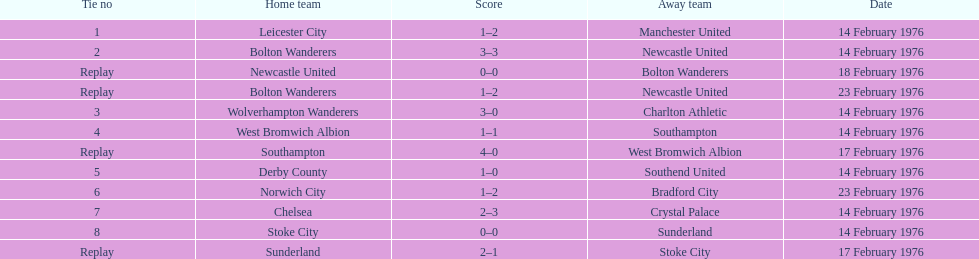How many contests involving sunderland are enumerated here? 2. 